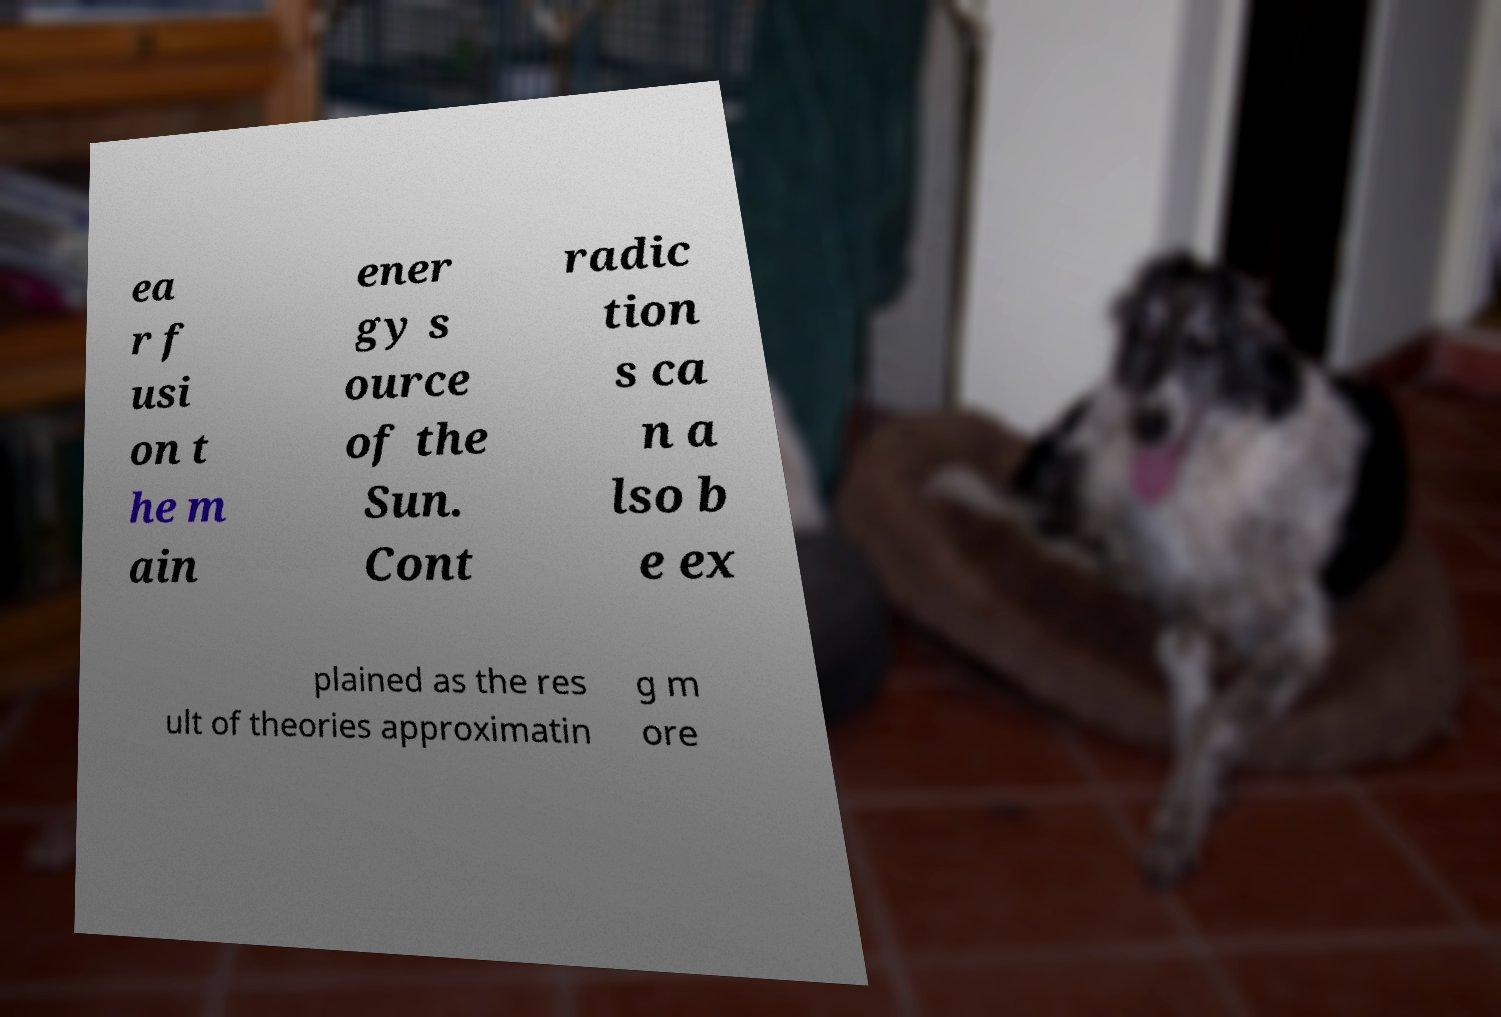There's text embedded in this image that I need extracted. Can you transcribe it verbatim? ea r f usi on t he m ain ener gy s ource of the Sun. Cont radic tion s ca n a lso b e ex plained as the res ult of theories approximatin g m ore 